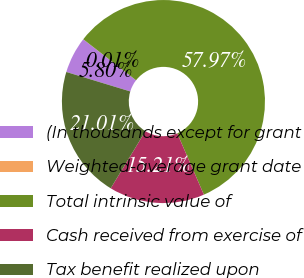Convert chart. <chart><loc_0><loc_0><loc_500><loc_500><pie_chart><fcel>(In thousands except for grant<fcel>Weighted-average grant date<fcel>Total intrinsic value of<fcel>Cash received from exercise of<fcel>Tax benefit realized upon<nl><fcel>5.8%<fcel>0.01%<fcel>57.97%<fcel>15.21%<fcel>21.01%<nl></chart> 